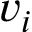Convert formula to latex. <formula><loc_0><loc_0><loc_500><loc_500>v _ { i }</formula> 